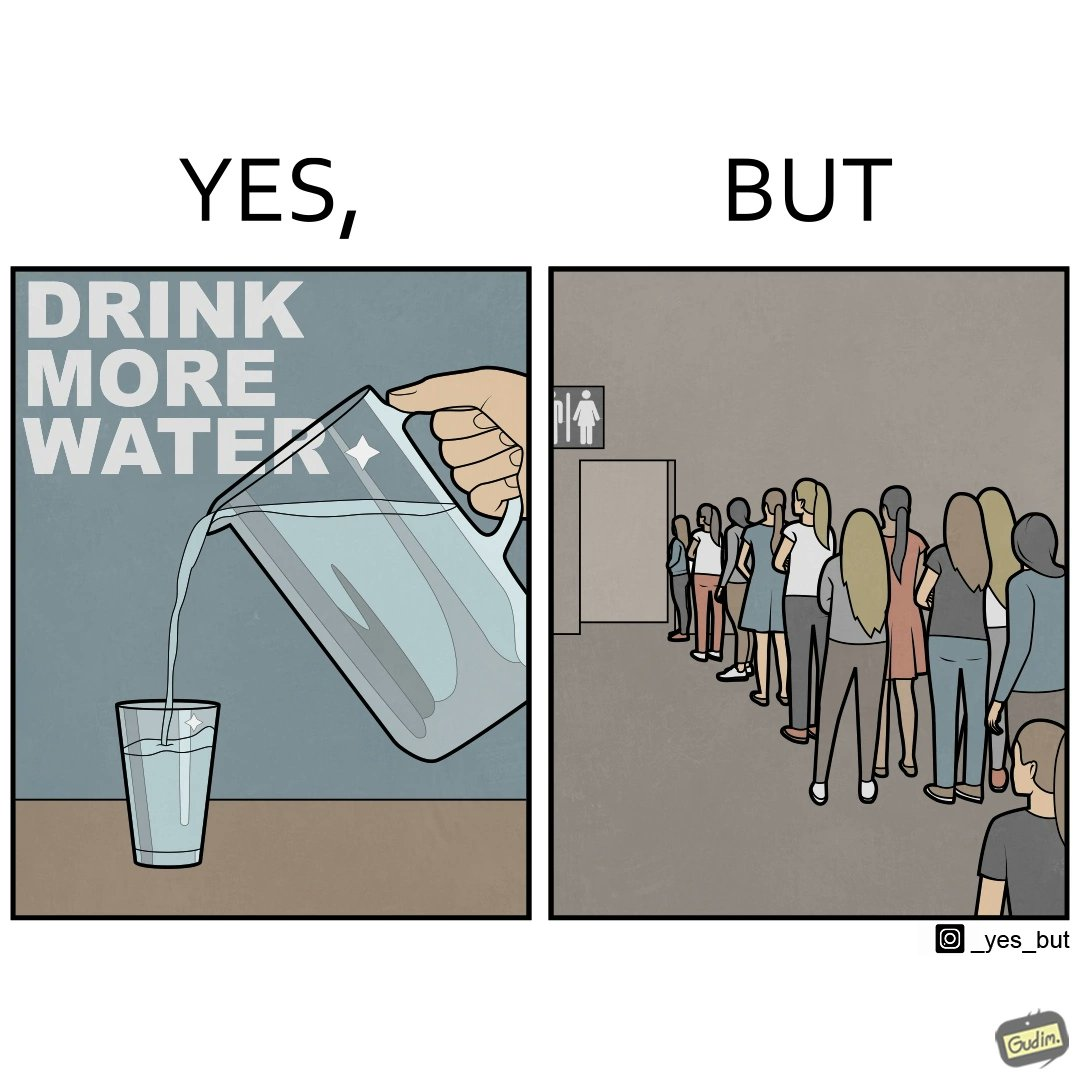What is shown in the left half versus the right half of this image? In the left part of the image: A banner that says "Drink more water" with an image of a jug pouring water into a glass. In the right part of the image: a very long queue in front of the public toilet 